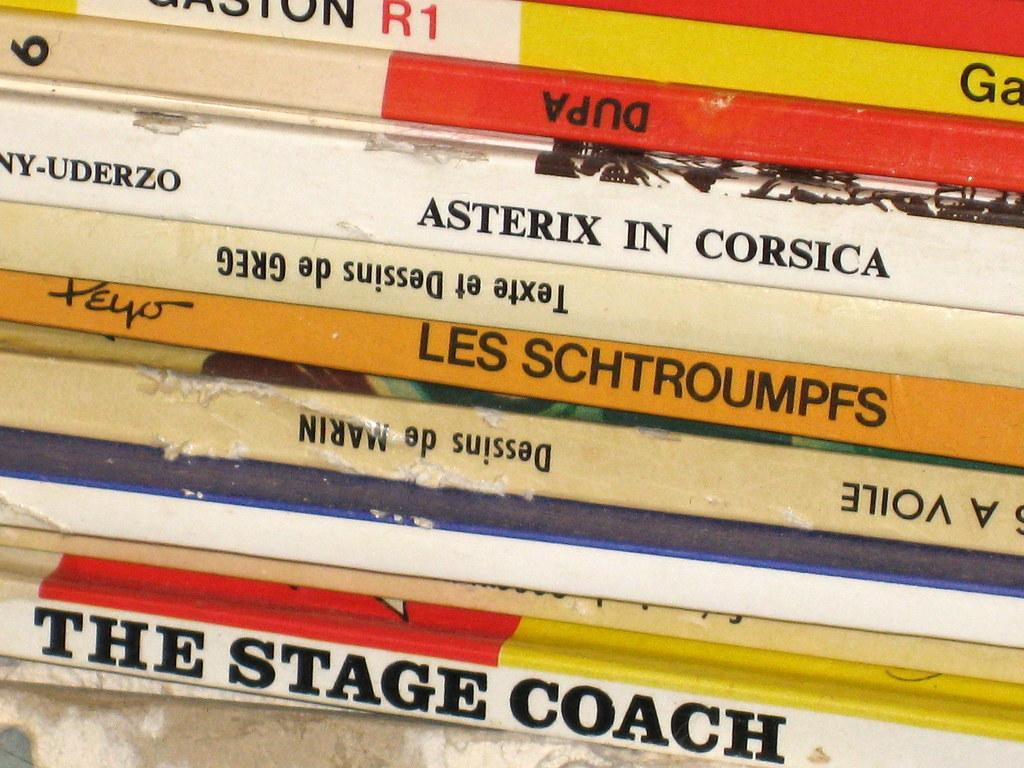<image>
Present a compact description of the photo's key features. The Stage Coach sits on the bottom of a stack of books 